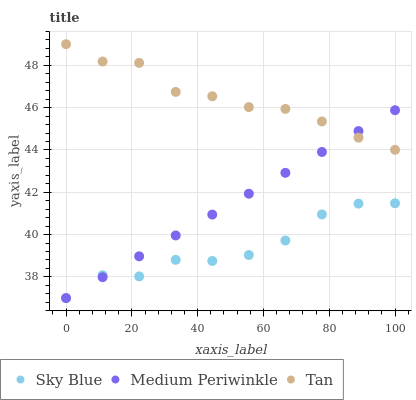Does Sky Blue have the minimum area under the curve?
Answer yes or no. Yes. Does Tan have the maximum area under the curve?
Answer yes or no. Yes. Does Medium Periwinkle have the minimum area under the curve?
Answer yes or no. No. Does Medium Periwinkle have the maximum area under the curve?
Answer yes or no. No. Is Medium Periwinkle the smoothest?
Answer yes or no. Yes. Is Sky Blue the roughest?
Answer yes or no. Yes. Is Tan the smoothest?
Answer yes or no. No. Is Tan the roughest?
Answer yes or no. No. Does Sky Blue have the lowest value?
Answer yes or no. Yes. Does Tan have the lowest value?
Answer yes or no. No. Does Tan have the highest value?
Answer yes or no. Yes. Does Medium Periwinkle have the highest value?
Answer yes or no. No. Is Sky Blue less than Tan?
Answer yes or no. Yes. Is Tan greater than Sky Blue?
Answer yes or no. Yes. Does Medium Periwinkle intersect Sky Blue?
Answer yes or no. Yes. Is Medium Periwinkle less than Sky Blue?
Answer yes or no. No. Is Medium Periwinkle greater than Sky Blue?
Answer yes or no. No. Does Sky Blue intersect Tan?
Answer yes or no. No. 